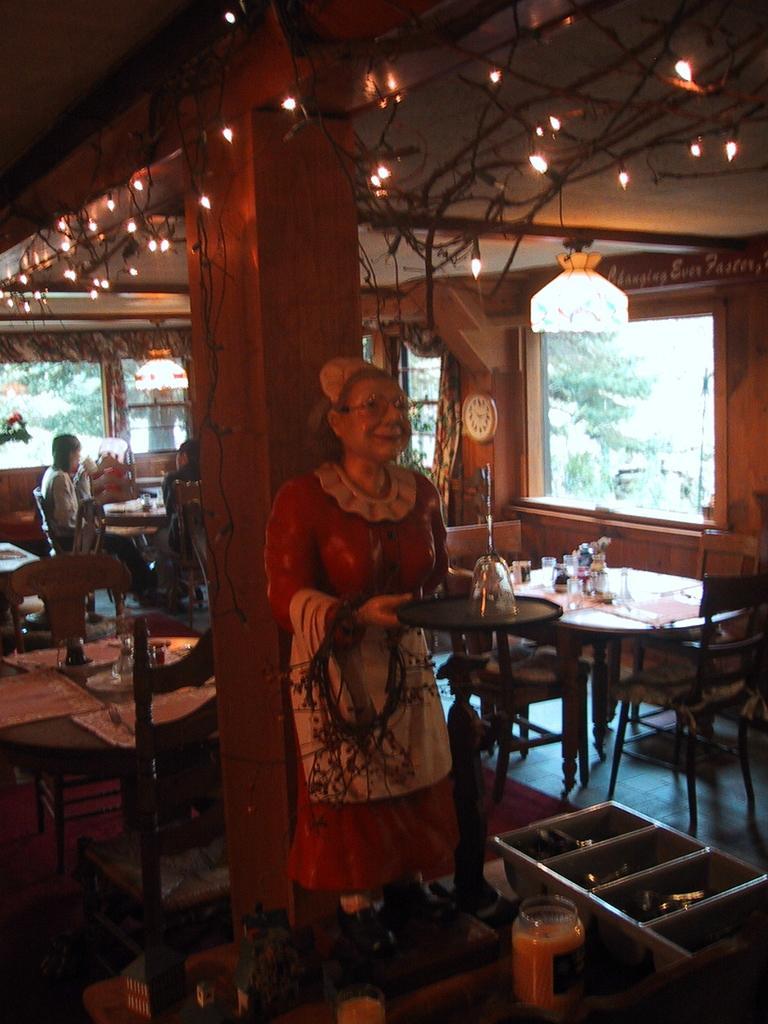Describe this image in one or two sentences. In the middle there is a woman statue holding a tray ,a glass on that. In the left there is a table in front of the table there are two person sitting on the chair. At the top there are many lights. In the background there is a window and tree. To the right there is a table in front of the table there is a chair. 